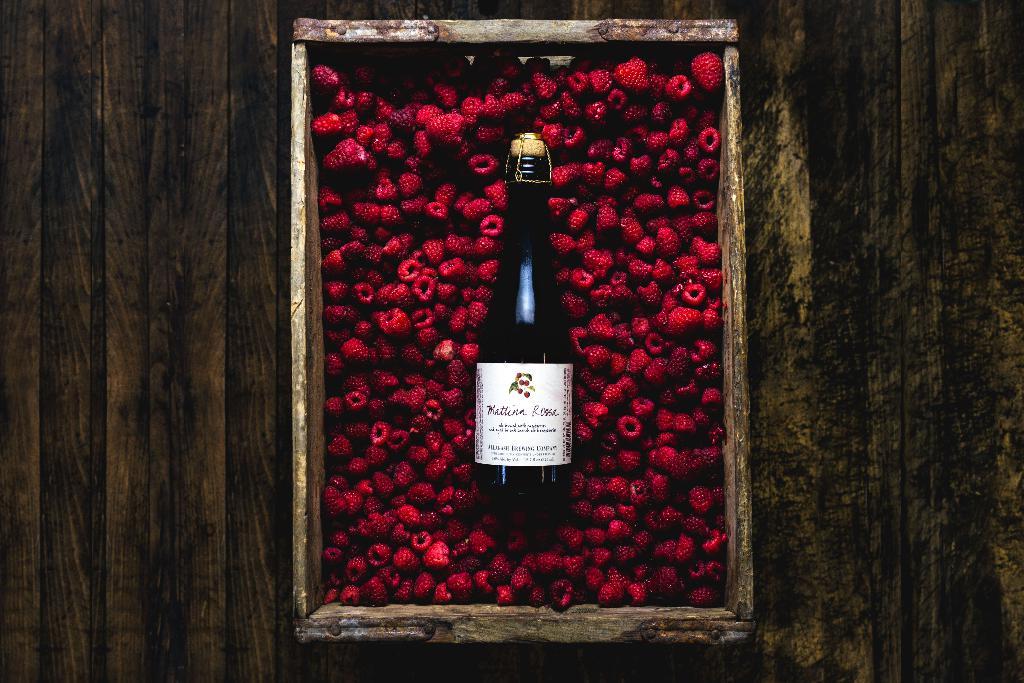What kind of drink is that?
Your answer should be compact. Wine. 